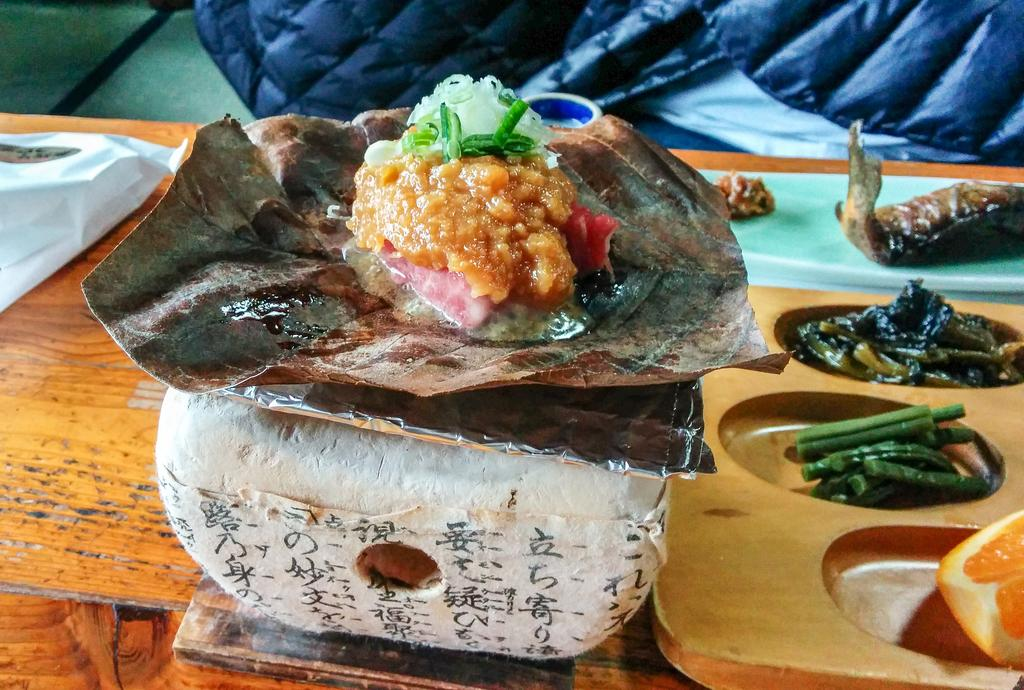What is the food on in the image? The food is on a silver foil in the image. What type of surface is the silver foil placed on? The silver foil is placed on a wooden table. What can be seen on the right side of the image? There is a tray on the right side of the image. What items are contained in the tray? The tray contains veggies, an orange, and fish. Is there a lawyer sitting on a swing in the image? No, there is no lawyer or swing present in the image. 